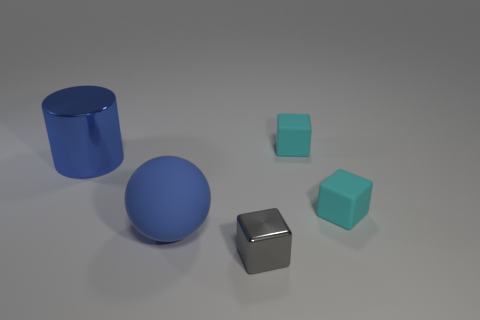Subtract all green cubes. Subtract all green balls. How many cubes are left? 3 Add 1 rubber objects. How many objects exist? 6 Subtract all cubes. How many objects are left? 2 Add 4 small gray metal blocks. How many small gray metal blocks are left? 5 Add 4 brown cylinders. How many brown cylinders exist? 4 Subtract 0 purple cylinders. How many objects are left? 5 Subtract all large cyan metallic objects. Subtract all big blue spheres. How many objects are left? 4 